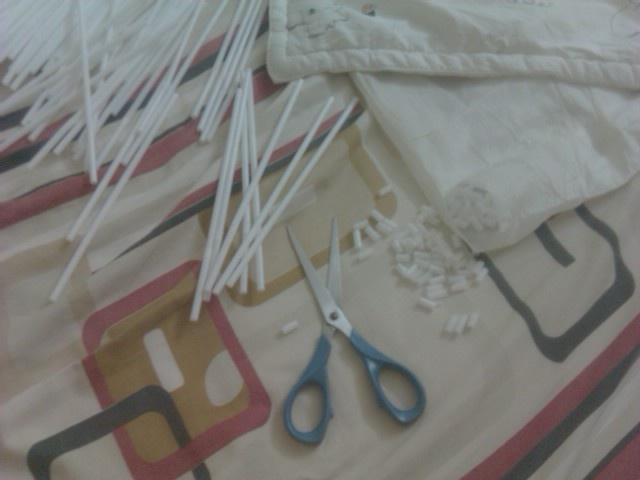Describe the objects in this image and their specific colors. I can see bed in gray tones and scissors in darkgray, gray, and blue tones in this image. 